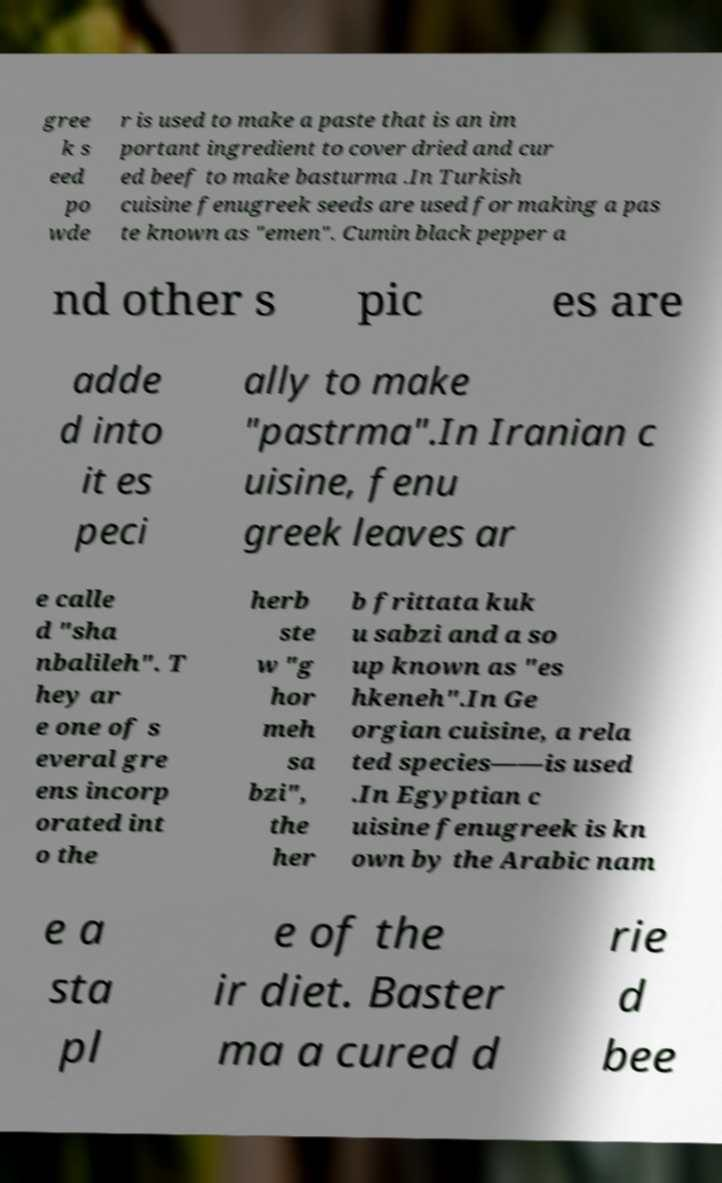For documentation purposes, I need the text within this image transcribed. Could you provide that? gree k s eed po wde r is used to make a paste that is an im portant ingredient to cover dried and cur ed beef to make basturma .In Turkish cuisine fenugreek seeds are used for making a pas te known as "emen". Cumin black pepper a nd other s pic es are adde d into it es peci ally to make "pastrma".In Iranian c uisine, fenu greek leaves ar e calle d "sha nbalileh". T hey ar e one of s everal gre ens incorp orated int o the herb ste w "g hor meh sa bzi", the her b frittata kuk u sabzi and a so up known as "es hkeneh".In Ge orgian cuisine, a rela ted species——is used .In Egyptian c uisine fenugreek is kn own by the Arabic nam e a sta pl e of the ir diet. Baster ma a cured d rie d bee 